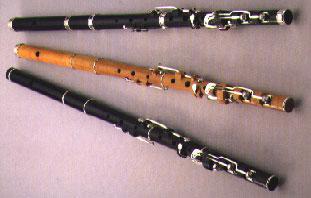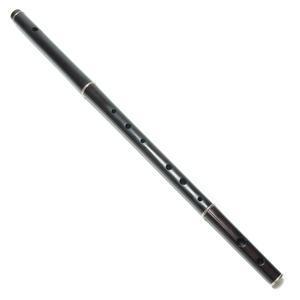The first image is the image on the left, the second image is the image on the right. For the images displayed, is the sentence "One image contains at least two flute sticks positioned with one end together and the other end fanning out." factually correct? Answer yes or no. Yes. The first image is the image on the left, the second image is the image on the right. Given the left and right images, does the statement "There are exactly two flutes." hold true? Answer yes or no. No. 